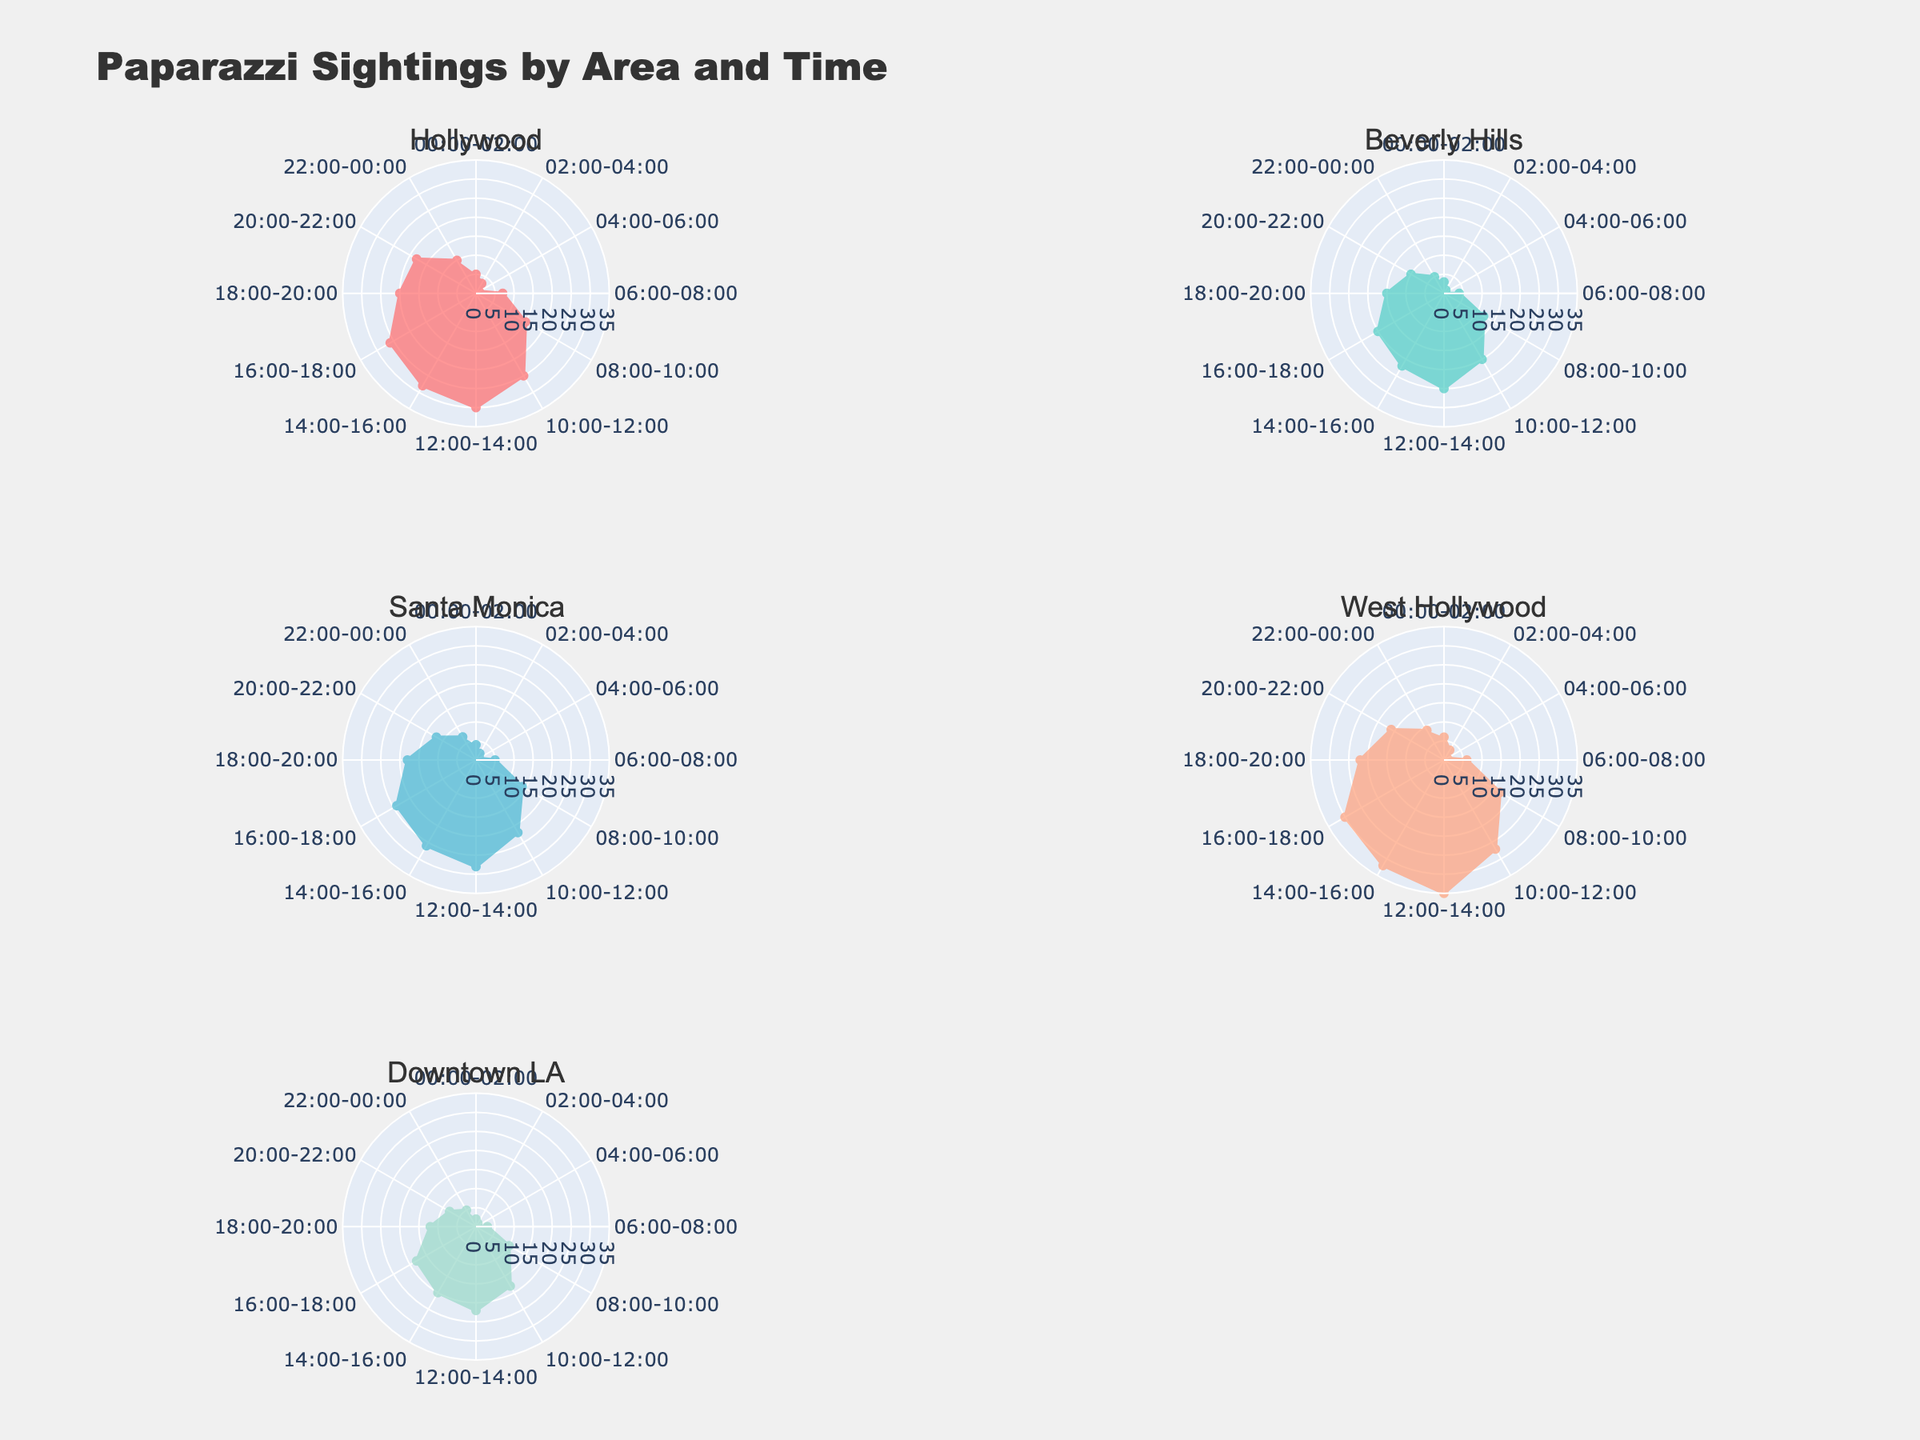What's the title of the figure? The title can be found at the top of the plot. The title text says "Paparazzi Sightings by Area and Time".
Answer: Paparazzi Sightings by Area and Time How many city areas are there in the figure? Each subplot represents a different city area. There are 5 subplots, one for each area: Hollywood, Beverly Hills, Santa Monica, West Hollywood, and Downtown LA.
Answer: 5 Which city area shows the highest frequency for any given time period and what is that frequency? The frequency can be found on the radial axis, and the highest peak in the subplots represents the highest frequency. West Hollywood has the highest frequency with 35 sightings in the 12:00-14:00 time slot.
Answer: West Hollywood, 35 During which time period does Santa Monica have the highest frequency of sightings? By looking at the peak point in the Santa Monica subplot, we can see that the highest frequency occurs between 12:00-14:00.
Answer: 12:00-14:00 Which two time periods have the lowest sightings in Hollywood, and what are those frequencies? By observing the radial distance of the points in Hollywood's subplot, we can see that the lowest frequencies occur between 04:00-06:00 with a frequency of 1, and 02:00-04:00 with a frequency of 3.
Answer: 04:00-06:00, 1 and 02:00-04:00, 3 Compare the number of sightings in Beverly Hills and Downtown LA between 06:00-08:00. Which one has more sightings? Referring to the radial points for both time slots, Beverly Hills has 4 sightings and Downtown LA has 3 sightings. Thus, Beverly Hills has one more sighting during this time slot.
Answer: Beverly Hills Which city area displays a consistent pattern of increasing sightings from 00:00-06:00? By examining the shape and trend of the lines in each subplot for the time period 00:00-06:00, none of the areas show increasing sightings consistently during 00:00-06:00.
Answer: None In the period from 18:00-20:00, which two areas have the closest frequencies and what are they? By comparing the radial points for each area in the 18:00-20:00 time slot, West Hollywood has 22 sightings, Hollywood 20, Beverly Hills 15, Santa Monica 18, and Downtown LA 12. Hollywood and Santa Monica, with frequencies of 20 and 18, are the closest.
Answer: Hollywood and Santa Monica, 20 and 18 What is the average frequency of sightings in Downtown LA during the day (06:00-18:00)? To calculate the average, sum the frequencies from 06:00-08:00 (3), 08:00-10:00 (10), 10:00-12:00 (18), 12:00-14:00 (22), 14:00-16:00 (20), and 16:00-18:00 (18). The total is 91. Divide by the number of periods (6).
Answer: 15.17 